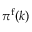<formula> <loc_0><loc_0><loc_500><loc_500>\pi ^ { \mathrm f } ( k )</formula> 